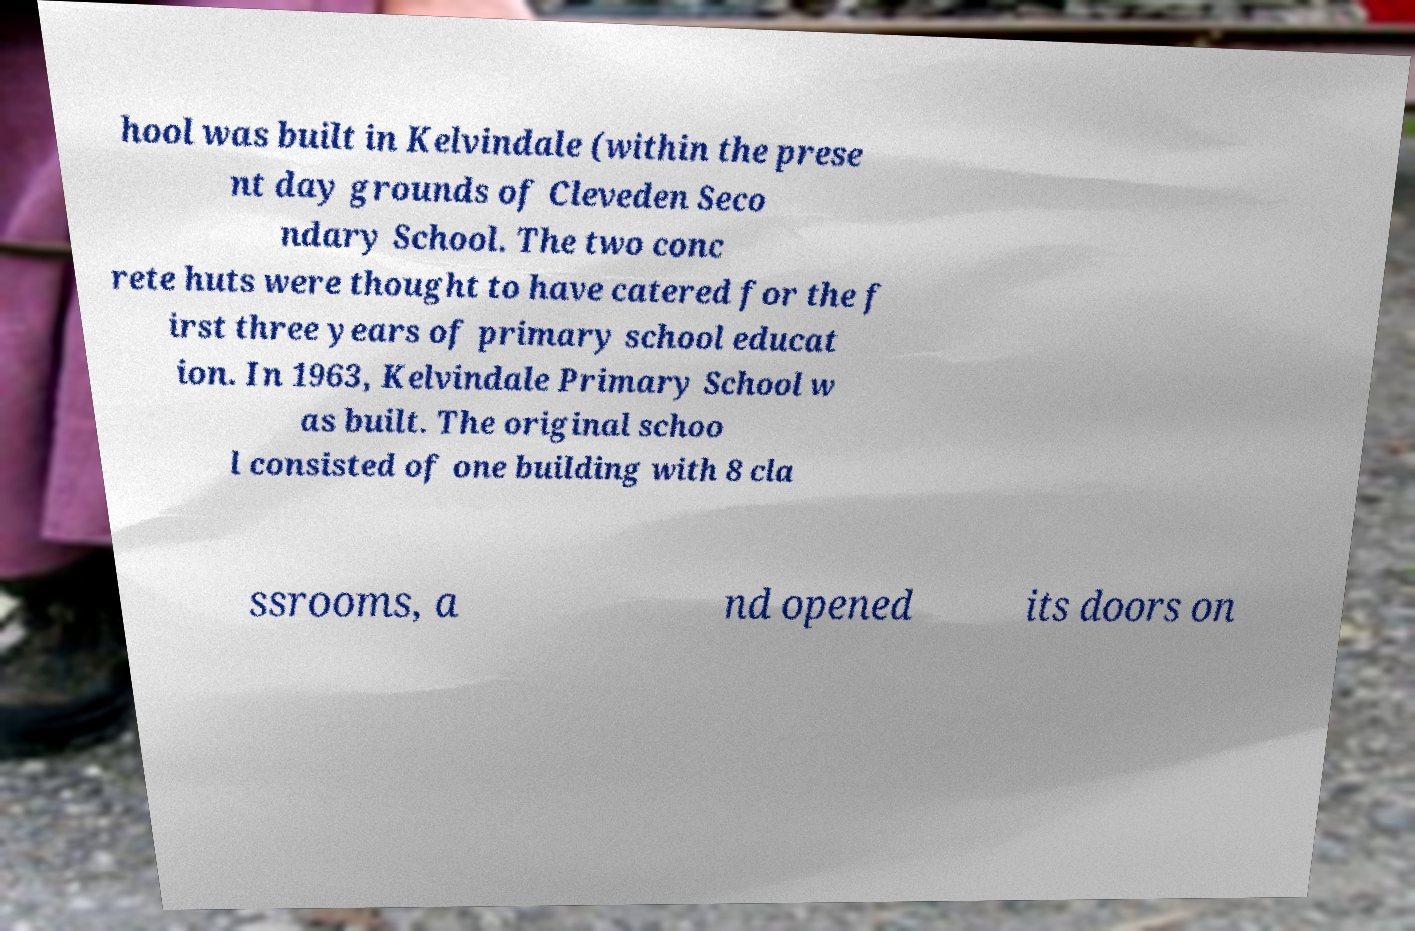Can you read and provide the text displayed in the image?This photo seems to have some interesting text. Can you extract and type it out for me? hool was built in Kelvindale (within the prese nt day grounds of Cleveden Seco ndary School. The two conc rete huts were thought to have catered for the f irst three years of primary school educat ion. In 1963, Kelvindale Primary School w as built. The original schoo l consisted of one building with 8 cla ssrooms, a nd opened its doors on 